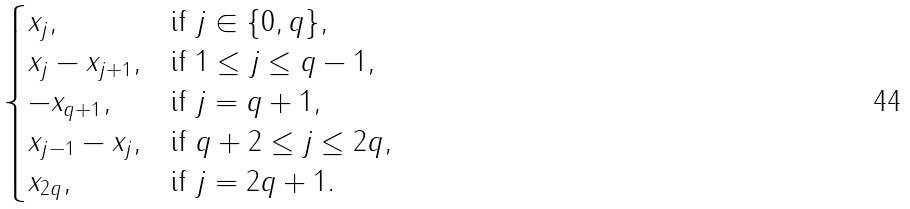Convert formula to latex. <formula><loc_0><loc_0><loc_500><loc_500>\begin{cases} x _ { j } , & \text {if} \ j \in \{ 0 , q \} , \\ x _ { j } - x _ { j + 1 } , & \text {if} \ 1 \leq j \leq q - 1 , \\ - x _ { q + 1 } , & \text {if} \ j = q + 1 , \\ x _ { j - 1 } - x _ { j } , & \text {if} \ q + 2 \leq j \leq 2 q , \\ x _ { 2 q } , & \text {if} \ j = 2 q + 1 . \end{cases}</formula> 